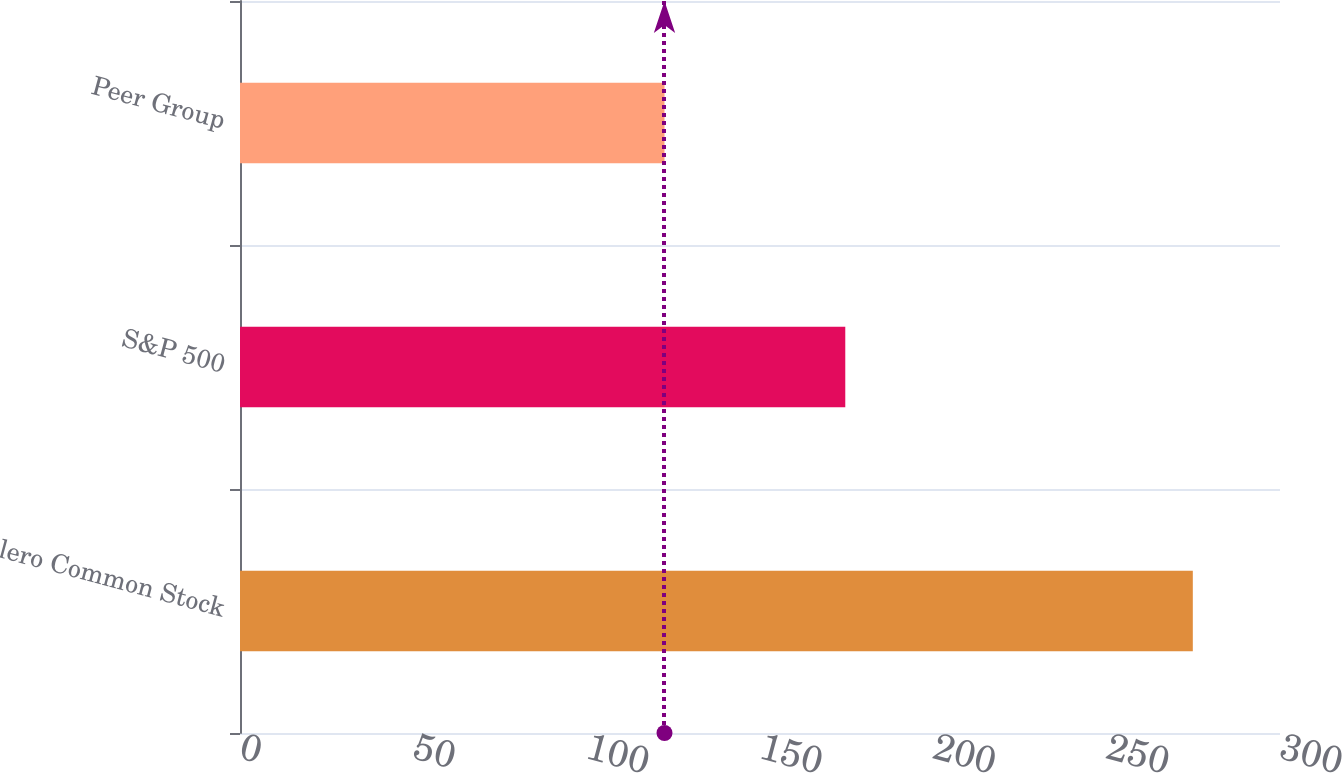Convert chart. <chart><loc_0><loc_0><loc_500><loc_500><bar_chart><fcel>Valero Common Stock<fcel>S&P 500<fcel>Peer Group<nl><fcel>274.85<fcel>174.6<fcel>122.45<nl></chart> 